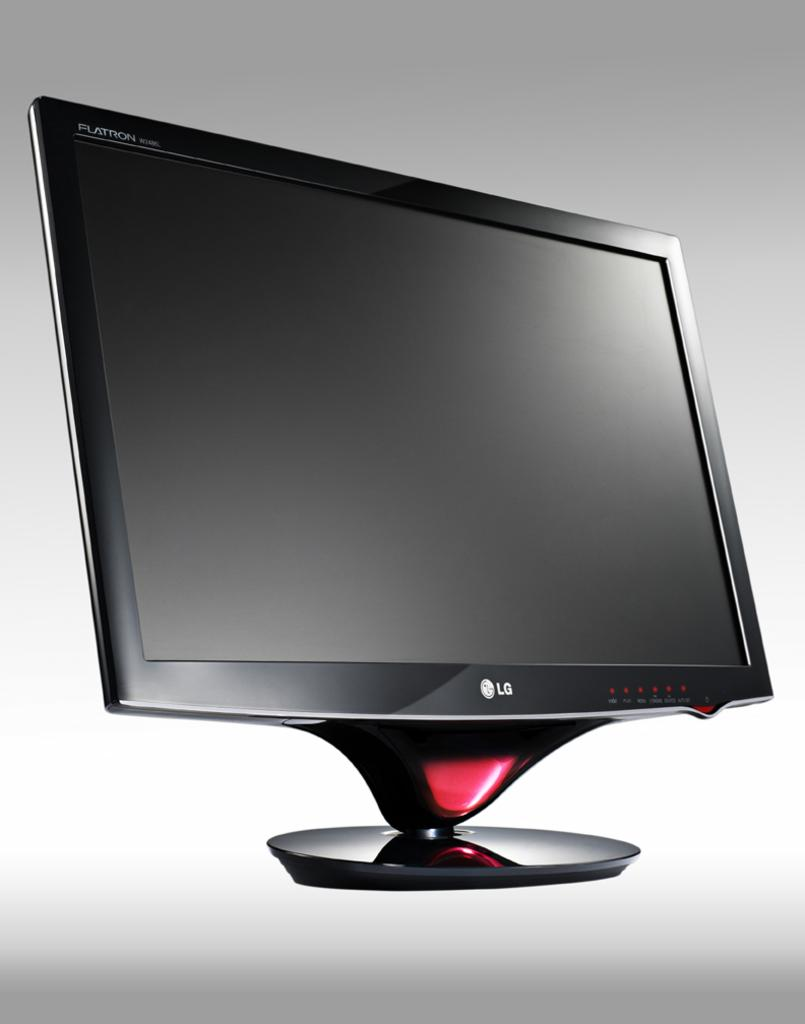What is the main subject in the center of the image? There is a monitor in the center of the image. What type of loaf can be seen being baked in the monitor? There is no loaf present in the monitor; it is displaying a monitor, not a bakery scene. 